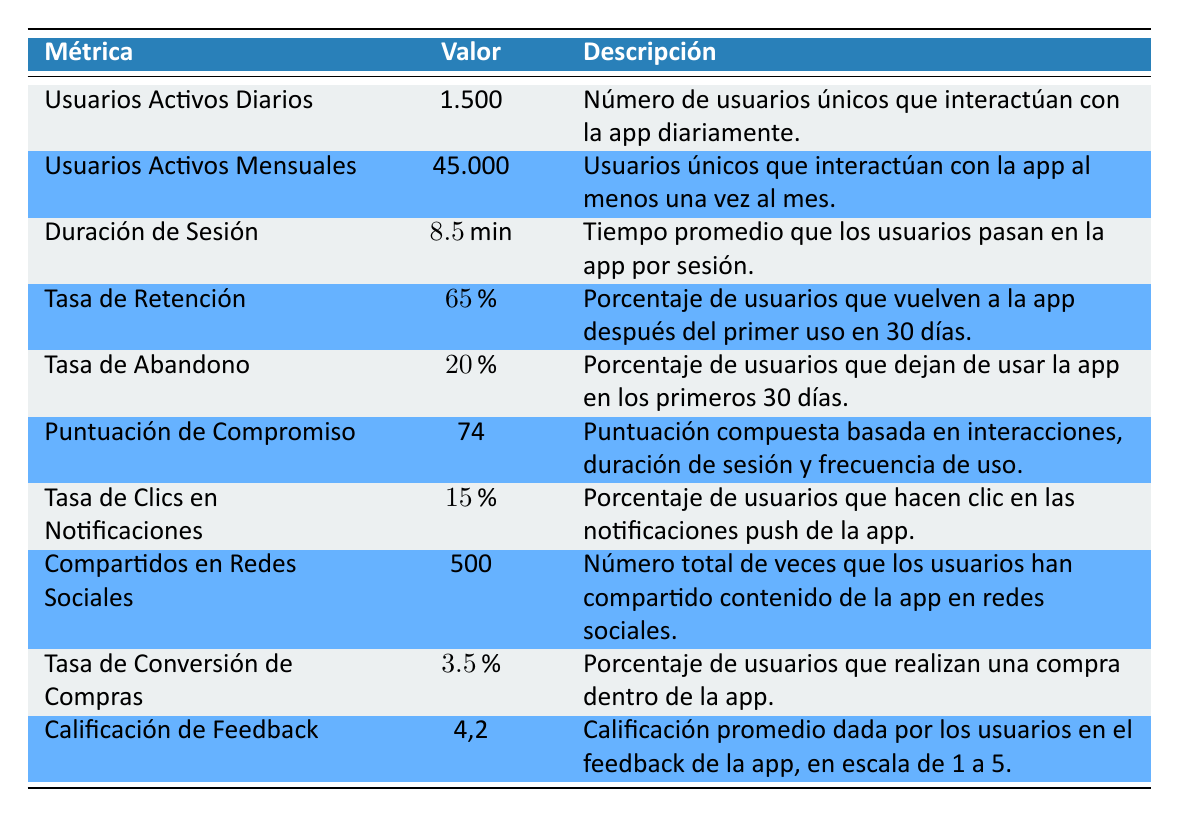What is the value of the Daily Active Users metric? The Daily Active Users metric shows that there are 1,500 unique users engaging with the app daily.
Answer: 1,500 What percentage of users return to the app after their first use within 30 days? The Retention Rate metric indicates that 65% of users return to the app within 30 days after their first use.
Answer: 65% What is the average session length in minutes? The Session Length metric reveals that users spend an average of 8.5 minutes in the app during a single session.
Answer: 8.5 Is the Churn Rate greater than 15%? The Churn Rate is stated as 20%, which is indeed greater than 15%.
Answer: Yes What is the difference between Monthly Active Users and Daily Active Users? To calculate the difference, subtract Daily Active Users (1,500) from Monthly Active Users (45,000): 45,000 - 1,500 = 43,500.
Answer: 43,500 What is the average feedback rating given by users in the app feedback? The Feedback Rating metric tells us that the average rating by users is 4.2 on a scale of 1 to 5.
Answer: 4.2 Do users engage with the app extensively given the high User Engagement Score? A User Engagement Score of 74, as indicated in the table, suggests that users are engaging relatively well with the app.
Answer: Yes What is the total number of social media shares? From the table, we see that the number of times users have shared app content on social media is 500.
Answer: 500 What is the average of the Churn Rate and Retention Rate? To find the average, add the Churn Rate (20) and Retention Rate (65) and divide by 2: (20 + 65) / 2 = 42.5.
Answer: 42.5 